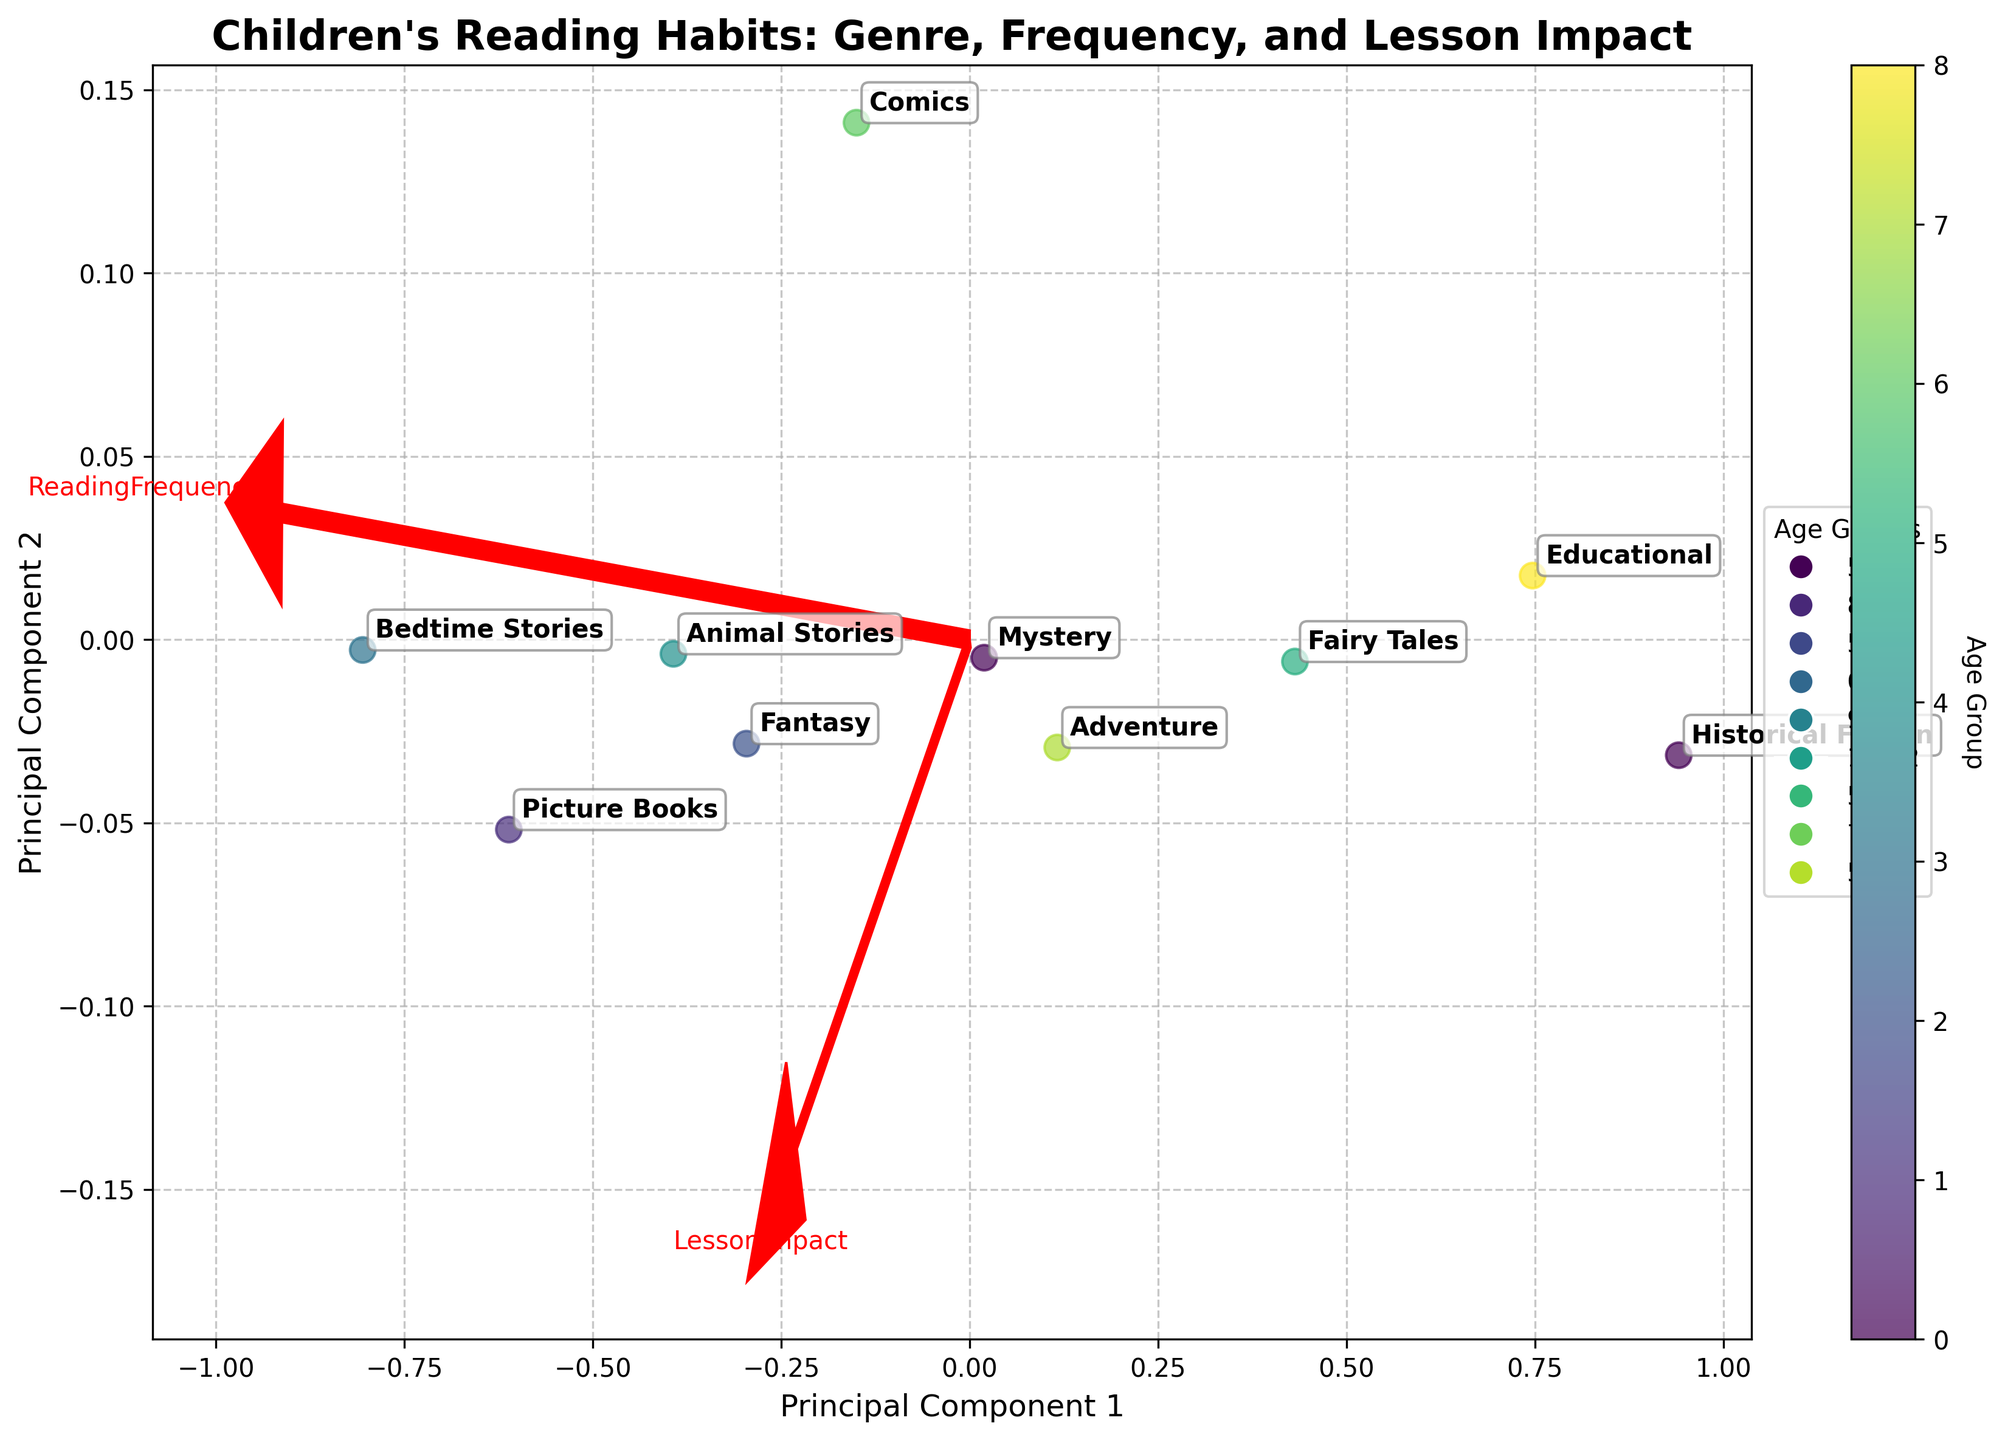What is the title of the figure? The title of the figure is typically found at the top of the plot and it summarizes what the figure is about. In this case, the title is "Children's Reading Habits: Genre, Frequency, and Lesson Impact".
Answer: Children's Reading Habits: Genre, Frequency, and Lesson Impact How many genres are represented in the biplot? To find the number of genres, we need to count the number of distinct labels in the plot. Each label represents a different genre.
Answer: 10 Which genre has the highest frequency of reading? To find this, look for the genre label closest to the arrow representing the highest value on the 'ReadingFrequency' axis. 'Bedtime Stories' is closest to the high end of this axis.
Answer: Bedtime Stories What age group reads 'Educational' books the most? Each genre's data point is colored according to the age group. By finding the point labeled 'Educational' and noting its color, we can refer to the legend to determine the corresponding age group. The 'Educational' books point is within the age group 9-12.
Answer: 9-12 Which two genres are closest in terms of both reading frequency and lesson impact? By examining the proximity of data points on the biplot, 'Fairy Tales' and 'Adventure' are closest to each other.
Answer: Fairy Tales and Adventure What is the principal component that influences 'ReadingFrequency' the most? The arrow labeled 'ReadingFrequency' indicates the principal component influencing it. The direction and length of the arrow represent the influence, and this arrow points along Principal Component 1.
Answer: Principal Component 1 Compare the lesson impact of 'Historical Fiction' and 'Comics'. Which one has a higher impact? To compare, look at the position of the points labeled 'Historical Fiction' and 'Comics' along the 'LessonImpact' direction. 'Comics' is further along this axis compared to 'Historical Fiction'.
Answer: Comics Which genre has both high reading frequency and high lesson impact? By looking for a point that is positioned far along both the 'ReadingFrequency' and 'LessonImpact' arrows, 'Bedtime Stories' stands out as having high values for both.
Answer: Bedtime Stories Are there any genres that are predominantly read by the youngest age group (5-7)? To determine this, look for points in the color representing the 5-7 age group. 'Fantasy' and 'Picture Books' are prominently read by this age group.
Answer: Fantasy and Picture Books Which genre has the lowest reading frequency and lesson impact among the 10-12 age group? By identifying points colored for the 10-12 age group and looking for the one positioned lowest on both axes, 'Historical Fiction' has the lowest values for both among the 10-12 age group.
Answer: Historical Fiction 